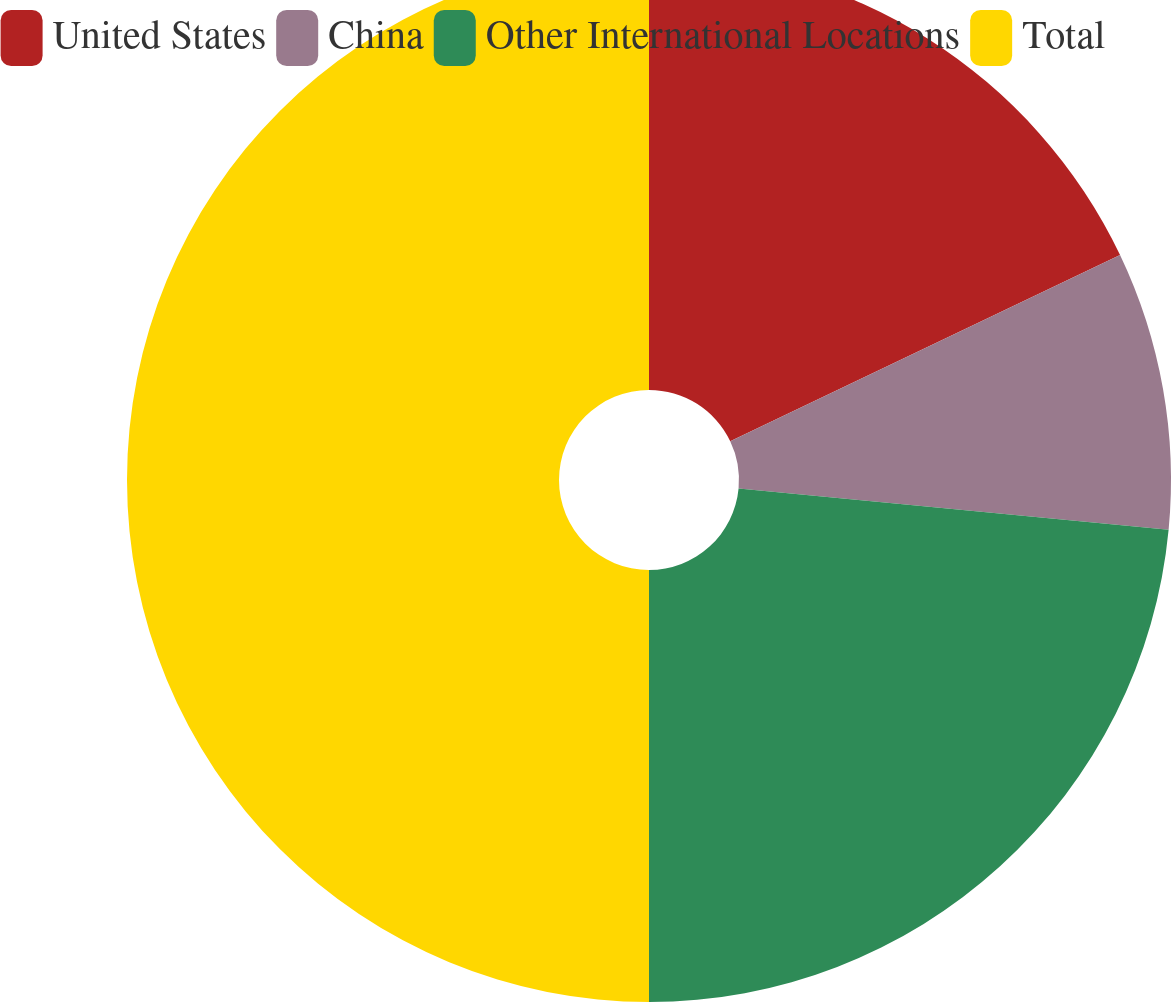<chart> <loc_0><loc_0><loc_500><loc_500><pie_chart><fcel>United States<fcel>China<fcel>Other International Locations<fcel>Total<nl><fcel>17.91%<fcel>8.61%<fcel>23.48%<fcel>50.0%<nl></chart> 